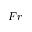Convert formula to latex. <formula><loc_0><loc_0><loc_500><loc_500>F r</formula> 